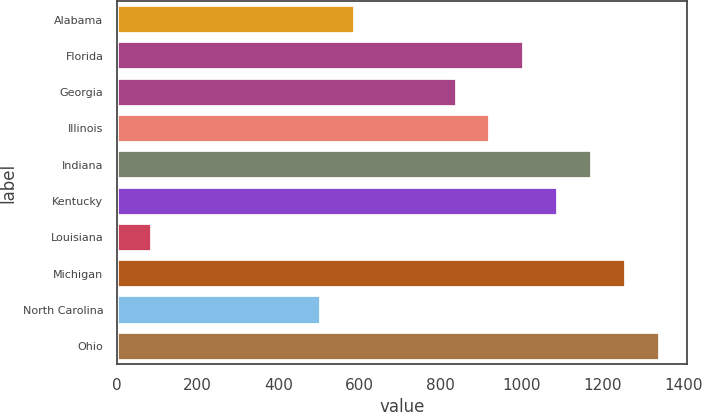Convert chart. <chart><loc_0><loc_0><loc_500><loc_500><bar_chart><fcel>Alabama<fcel>Florida<fcel>Georgia<fcel>Illinois<fcel>Indiana<fcel>Kentucky<fcel>Louisiana<fcel>Michigan<fcel>North Carolina<fcel>Ohio<nl><fcel>588.9<fcel>1007.4<fcel>840<fcel>923.7<fcel>1174.8<fcel>1091.1<fcel>86.7<fcel>1258.5<fcel>505.2<fcel>1342.2<nl></chart> 